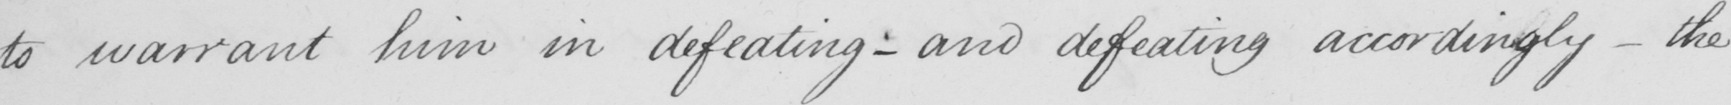Please provide the text content of this handwritten line. to warrant him in defeating  _  and defeating accordingly  _  the 